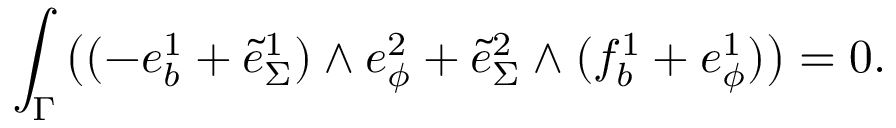Convert formula to latex. <formula><loc_0><loc_0><loc_500><loc_500>\int _ { \Gamma } \left ( ( - e _ { b } ^ { 1 } + \tilde { e } _ { \Sigma } ^ { 1 } ) \wedge e _ { \phi } ^ { 2 } + \tilde { e } _ { \Sigma } ^ { 2 } \wedge ( f _ { b } ^ { 1 } + e _ { \phi } ^ { 1 } ) \right ) = 0 .</formula> 